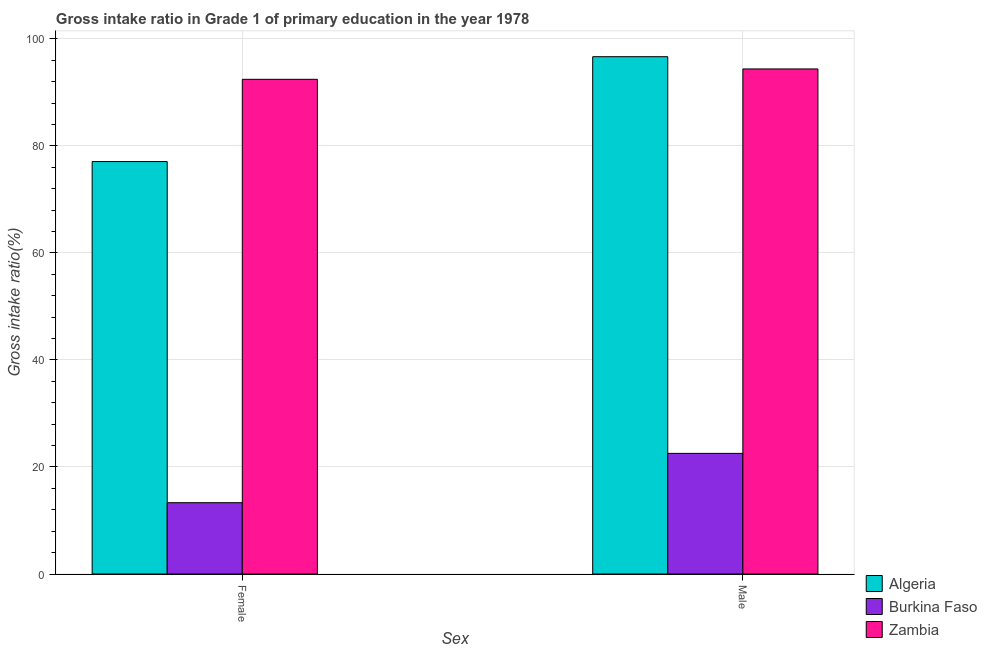How many bars are there on the 2nd tick from the right?
Give a very brief answer. 3. What is the label of the 2nd group of bars from the left?
Offer a very short reply. Male. What is the gross intake ratio(female) in Algeria?
Give a very brief answer. 77.07. Across all countries, what is the maximum gross intake ratio(male)?
Your answer should be very brief. 96.66. Across all countries, what is the minimum gross intake ratio(male)?
Offer a very short reply. 22.54. In which country was the gross intake ratio(male) maximum?
Make the answer very short. Algeria. In which country was the gross intake ratio(male) minimum?
Your response must be concise. Burkina Faso. What is the total gross intake ratio(female) in the graph?
Offer a terse response. 182.83. What is the difference between the gross intake ratio(female) in Algeria and that in Zambia?
Your response must be concise. -15.37. What is the difference between the gross intake ratio(male) in Zambia and the gross intake ratio(female) in Algeria?
Offer a terse response. 17.31. What is the average gross intake ratio(female) per country?
Provide a succinct answer. 60.94. What is the difference between the gross intake ratio(female) and gross intake ratio(male) in Zambia?
Provide a succinct answer. -1.94. In how many countries, is the gross intake ratio(male) greater than 40 %?
Provide a short and direct response. 2. What is the ratio of the gross intake ratio(male) in Burkina Faso to that in Algeria?
Ensure brevity in your answer.  0.23. Is the gross intake ratio(female) in Burkina Faso less than that in Algeria?
Provide a succinct answer. Yes. What does the 1st bar from the left in Female represents?
Your answer should be very brief. Algeria. What does the 1st bar from the right in Female represents?
Your answer should be compact. Zambia. How many countries are there in the graph?
Your answer should be very brief. 3. What is the difference between two consecutive major ticks on the Y-axis?
Keep it short and to the point. 20. Are the values on the major ticks of Y-axis written in scientific E-notation?
Your response must be concise. No. Does the graph contain any zero values?
Your response must be concise. No. Does the graph contain grids?
Your answer should be very brief. Yes. Where does the legend appear in the graph?
Your answer should be very brief. Bottom right. How many legend labels are there?
Provide a succinct answer. 3. What is the title of the graph?
Your answer should be compact. Gross intake ratio in Grade 1 of primary education in the year 1978. Does "Bulgaria" appear as one of the legend labels in the graph?
Keep it short and to the point. No. What is the label or title of the X-axis?
Provide a short and direct response. Sex. What is the label or title of the Y-axis?
Provide a succinct answer. Gross intake ratio(%). What is the Gross intake ratio(%) in Algeria in Female?
Offer a terse response. 77.07. What is the Gross intake ratio(%) of Burkina Faso in Female?
Your answer should be compact. 13.32. What is the Gross intake ratio(%) of Zambia in Female?
Give a very brief answer. 92.43. What is the Gross intake ratio(%) in Algeria in Male?
Ensure brevity in your answer.  96.66. What is the Gross intake ratio(%) in Burkina Faso in Male?
Keep it short and to the point. 22.54. What is the Gross intake ratio(%) of Zambia in Male?
Your answer should be compact. 94.37. Across all Sex, what is the maximum Gross intake ratio(%) of Algeria?
Provide a succinct answer. 96.66. Across all Sex, what is the maximum Gross intake ratio(%) in Burkina Faso?
Ensure brevity in your answer.  22.54. Across all Sex, what is the maximum Gross intake ratio(%) of Zambia?
Ensure brevity in your answer.  94.37. Across all Sex, what is the minimum Gross intake ratio(%) in Algeria?
Offer a terse response. 77.07. Across all Sex, what is the minimum Gross intake ratio(%) in Burkina Faso?
Ensure brevity in your answer.  13.32. Across all Sex, what is the minimum Gross intake ratio(%) of Zambia?
Your answer should be compact. 92.43. What is the total Gross intake ratio(%) of Algeria in the graph?
Your answer should be compact. 173.73. What is the total Gross intake ratio(%) of Burkina Faso in the graph?
Offer a terse response. 35.86. What is the total Gross intake ratio(%) of Zambia in the graph?
Keep it short and to the point. 186.81. What is the difference between the Gross intake ratio(%) in Algeria in Female and that in Male?
Provide a succinct answer. -19.6. What is the difference between the Gross intake ratio(%) in Burkina Faso in Female and that in Male?
Ensure brevity in your answer.  -9.21. What is the difference between the Gross intake ratio(%) of Zambia in Female and that in Male?
Ensure brevity in your answer.  -1.94. What is the difference between the Gross intake ratio(%) in Algeria in Female and the Gross intake ratio(%) in Burkina Faso in Male?
Keep it short and to the point. 54.53. What is the difference between the Gross intake ratio(%) of Algeria in Female and the Gross intake ratio(%) of Zambia in Male?
Provide a succinct answer. -17.31. What is the difference between the Gross intake ratio(%) in Burkina Faso in Female and the Gross intake ratio(%) in Zambia in Male?
Keep it short and to the point. -81.05. What is the average Gross intake ratio(%) in Algeria per Sex?
Your answer should be compact. 86.87. What is the average Gross intake ratio(%) in Burkina Faso per Sex?
Ensure brevity in your answer.  17.93. What is the average Gross intake ratio(%) in Zambia per Sex?
Your answer should be very brief. 93.4. What is the difference between the Gross intake ratio(%) of Algeria and Gross intake ratio(%) of Burkina Faso in Female?
Your response must be concise. 63.74. What is the difference between the Gross intake ratio(%) of Algeria and Gross intake ratio(%) of Zambia in Female?
Provide a short and direct response. -15.37. What is the difference between the Gross intake ratio(%) in Burkina Faso and Gross intake ratio(%) in Zambia in Female?
Offer a terse response. -79.11. What is the difference between the Gross intake ratio(%) of Algeria and Gross intake ratio(%) of Burkina Faso in Male?
Your answer should be compact. 74.13. What is the difference between the Gross intake ratio(%) in Algeria and Gross intake ratio(%) in Zambia in Male?
Offer a very short reply. 2.29. What is the difference between the Gross intake ratio(%) in Burkina Faso and Gross intake ratio(%) in Zambia in Male?
Your answer should be compact. -71.84. What is the ratio of the Gross intake ratio(%) of Algeria in Female to that in Male?
Your response must be concise. 0.8. What is the ratio of the Gross intake ratio(%) in Burkina Faso in Female to that in Male?
Give a very brief answer. 0.59. What is the ratio of the Gross intake ratio(%) of Zambia in Female to that in Male?
Your response must be concise. 0.98. What is the difference between the highest and the second highest Gross intake ratio(%) in Algeria?
Provide a short and direct response. 19.6. What is the difference between the highest and the second highest Gross intake ratio(%) in Burkina Faso?
Provide a short and direct response. 9.21. What is the difference between the highest and the second highest Gross intake ratio(%) in Zambia?
Keep it short and to the point. 1.94. What is the difference between the highest and the lowest Gross intake ratio(%) of Algeria?
Provide a short and direct response. 19.6. What is the difference between the highest and the lowest Gross intake ratio(%) of Burkina Faso?
Offer a very short reply. 9.21. What is the difference between the highest and the lowest Gross intake ratio(%) of Zambia?
Make the answer very short. 1.94. 